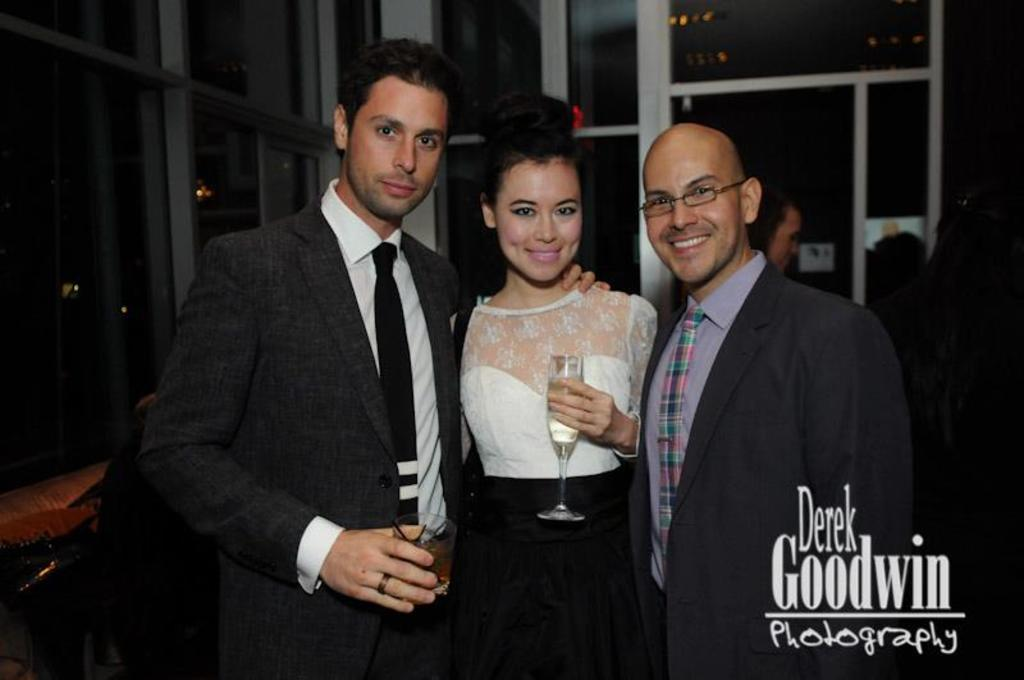How many people are present in the image? There are three people in the image: two men and one woman. What is the woman holding in the image? The woman is holding a glass. What type of veil is the woman wearing in the image? There is no veil present in the image; the woman is holding a glass. What decision is the woman making in the image? The image does not depict the woman making a decision; it only shows her holding a glass. 